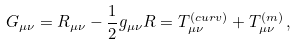Convert formula to latex. <formula><loc_0><loc_0><loc_500><loc_500>G _ { \mu \nu } = R _ { \mu \nu } - \frac { 1 } { 2 } g _ { \mu \nu } R = T ^ { ( c u r v ) } _ { \mu \nu } + T ^ { ( m ) } _ { \mu \nu } \, ,</formula> 